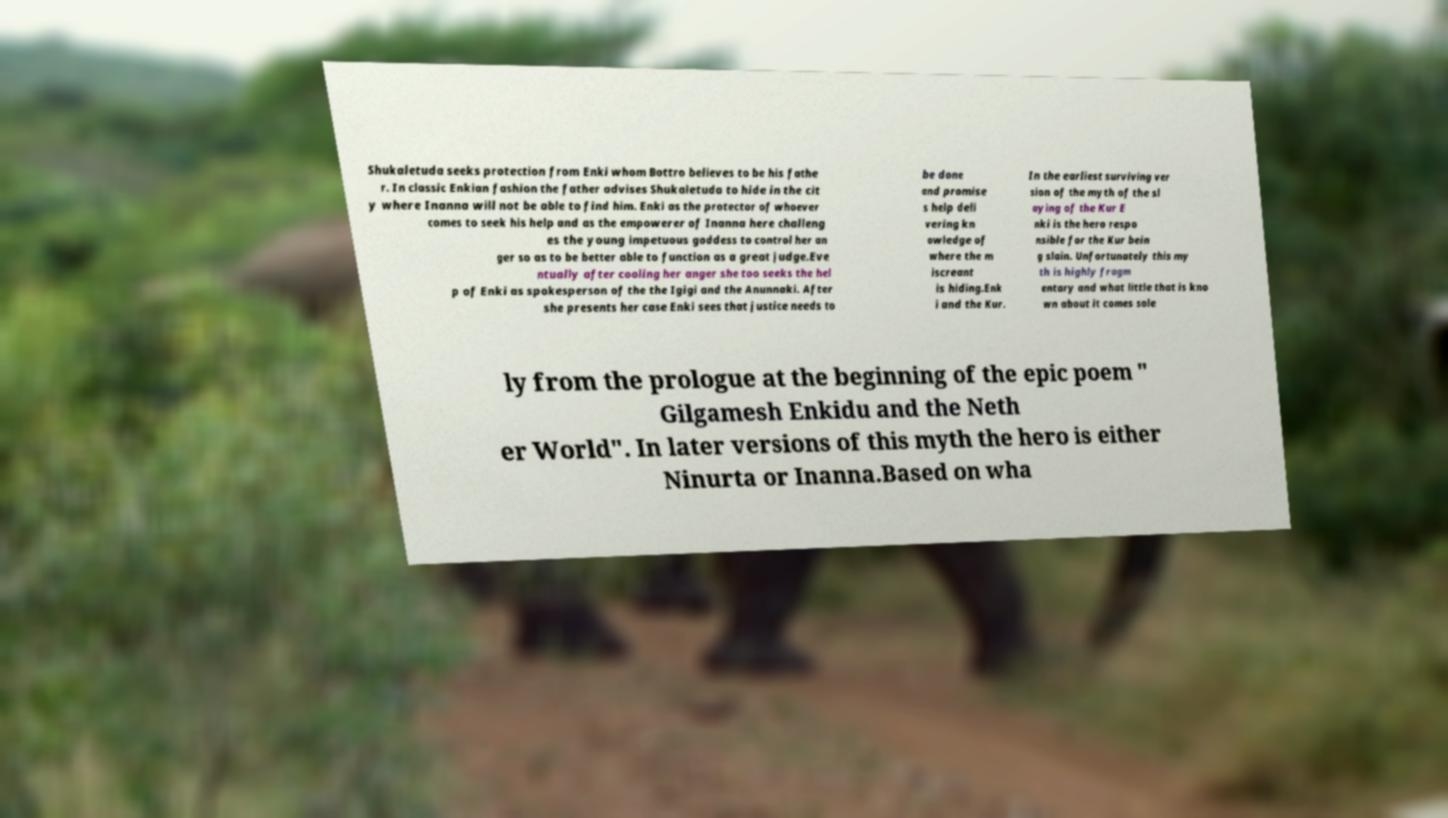There's text embedded in this image that I need extracted. Can you transcribe it verbatim? Shukaletuda seeks protection from Enki whom Bottro believes to be his fathe r. In classic Enkian fashion the father advises Shukaletuda to hide in the cit y where Inanna will not be able to find him. Enki as the protector of whoever comes to seek his help and as the empowerer of Inanna here challeng es the young impetuous goddess to control her an ger so as to be better able to function as a great judge.Eve ntually after cooling her anger she too seeks the hel p of Enki as spokesperson of the the Igigi and the Anunnaki. After she presents her case Enki sees that justice needs to be done and promise s help deli vering kn owledge of where the m iscreant is hiding.Enk i and the Kur. In the earliest surviving ver sion of the myth of the sl aying of the Kur E nki is the hero respo nsible for the Kur bein g slain. Unfortunately this my th is highly fragm entary and what little that is kno wn about it comes sole ly from the prologue at the beginning of the epic poem " Gilgamesh Enkidu and the Neth er World". In later versions of this myth the hero is either Ninurta or Inanna.Based on wha 